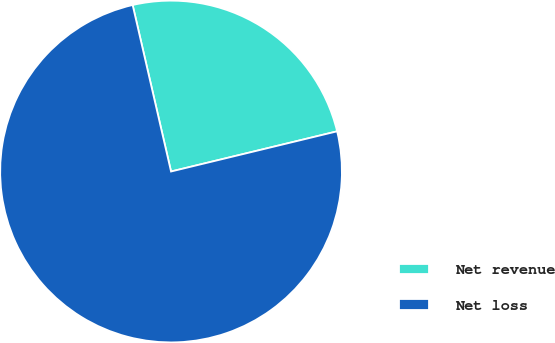Convert chart to OTSL. <chart><loc_0><loc_0><loc_500><loc_500><pie_chart><fcel>Net revenue<fcel>Net loss<nl><fcel>24.83%<fcel>75.17%<nl></chart> 